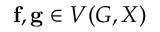Convert formula to latex. <formula><loc_0><loc_0><loc_500><loc_500>f , g \in V ( G , X )</formula> 